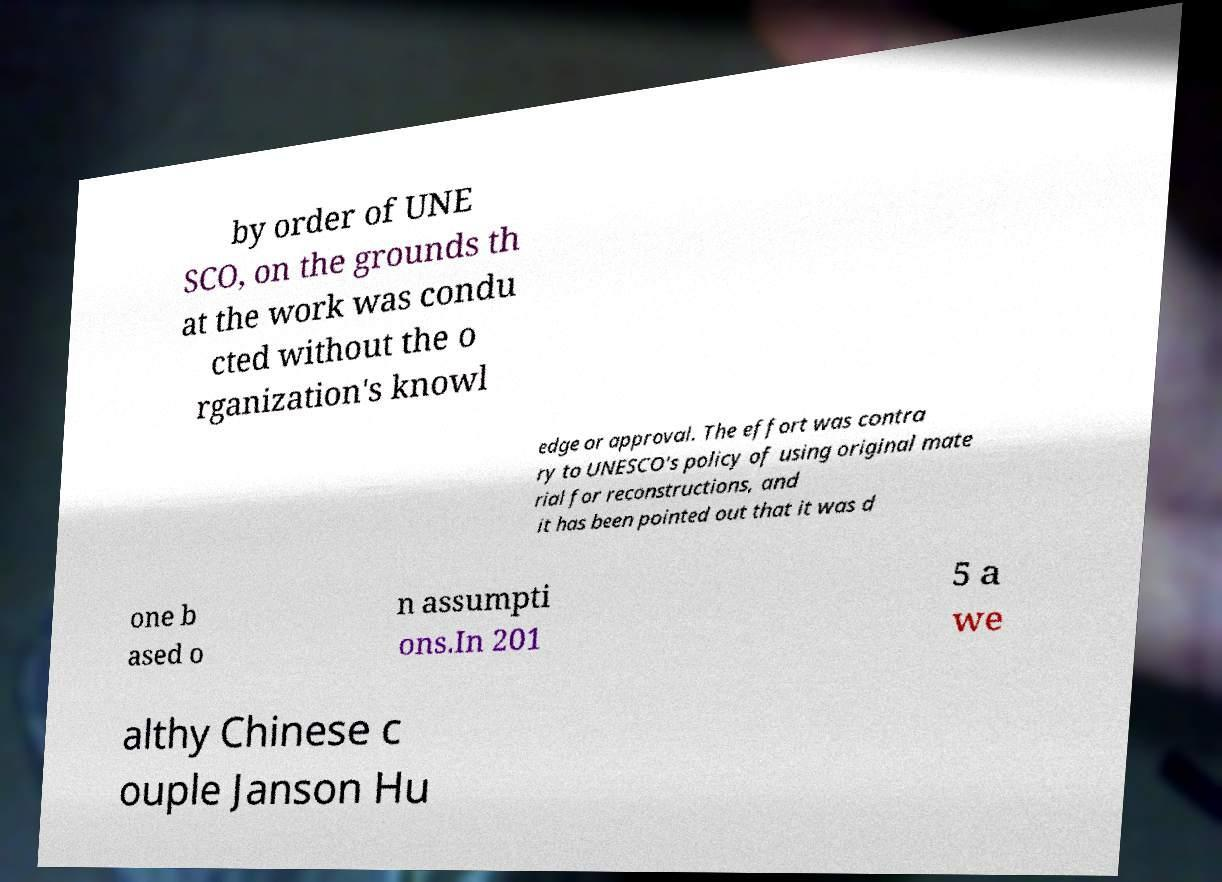Could you assist in decoding the text presented in this image and type it out clearly? by order of UNE SCO, on the grounds th at the work was condu cted without the o rganization's knowl edge or approval. The effort was contra ry to UNESCO's policy of using original mate rial for reconstructions, and it has been pointed out that it was d one b ased o n assumpti ons.In 201 5 a we althy Chinese c ouple Janson Hu 